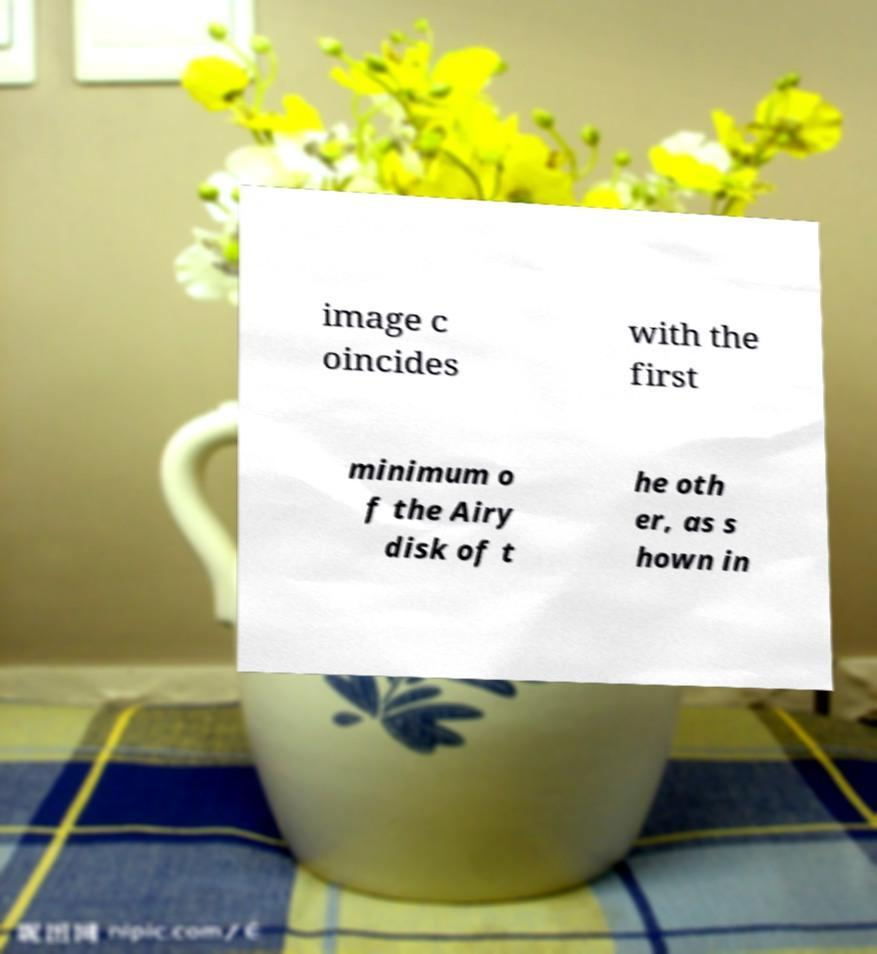Can you accurately transcribe the text from the provided image for me? image c oincides with the first minimum o f the Airy disk of t he oth er, as s hown in 